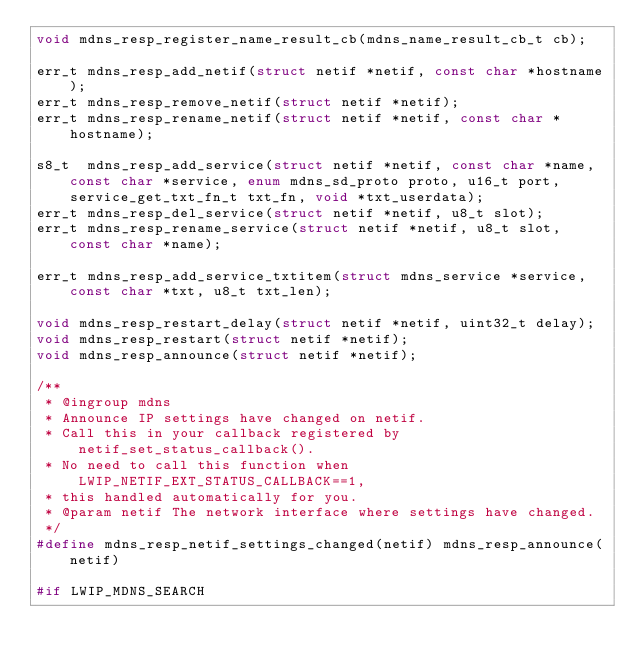<code> <loc_0><loc_0><loc_500><loc_500><_C_>void mdns_resp_register_name_result_cb(mdns_name_result_cb_t cb);

err_t mdns_resp_add_netif(struct netif *netif, const char *hostname);
err_t mdns_resp_remove_netif(struct netif *netif);
err_t mdns_resp_rename_netif(struct netif *netif, const char *hostname);

s8_t  mdns_resp_add_service(struct netif *netif, const char *name, const char *service, enum mdns_sd_proto proto, u16_t port, service_get_txt_fn_t txt_fn, void *txt_userdata);
err_t mdns_resp_del_service(struct netif *netif, u8_t slot);
err_t mdns_resp_rename_service(struct netif *netif, u8_t slot, const char *name);

err_t mdns_resp_add_service_txtitem(struct mdns_service *service, const char *txt, u8_t txt_len);

void mdns_resp_restart_delay(struct netif *netif, uint32_t delay);
void mdns_resp_restart(struct netif *netif);
void mdns_resp_announce(struct netif *netif);

/**
 * @ingroup mdns
 * Announce IP settings have changed on netif.
 * Call this in your callback registered by netif_set_status_callback().
 * No need to call this function when LWIP_NETIF_EXT_STATUS_CALLBACK==1,
 * this handled automatically for you.
 * @param netif The network interface where settings have changed.
 */
#define mdns_resp_netif_settings_changed(netif) mdns_resp_announce(netif)

#if LWIP_MDNS_SEARCH</code> 